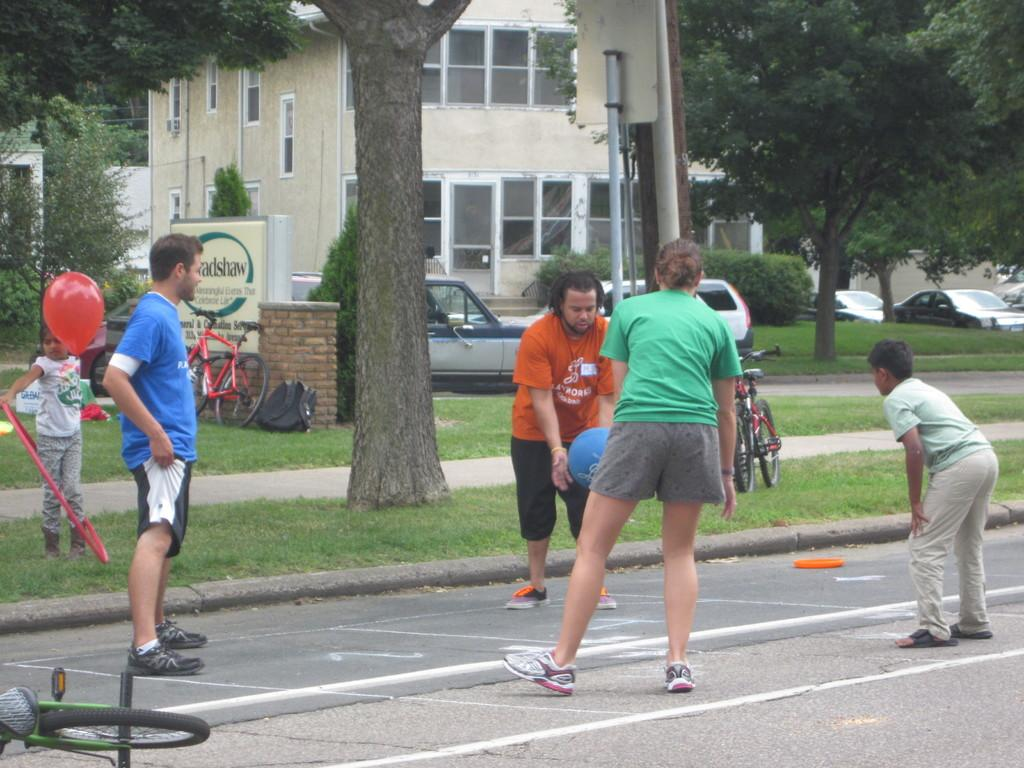What activity are the people in the image engaged in? The people in the image are playing a game. What type of vehicles can be seen in the image? There are bicycles and cars in the image. What type of vegetation is present in the image? There are green color trees in the image. What type of structure is visible in the image? There is a building in the image. Where can the store selling salt be found in the image? There is no store selling salt present in the image. What type of driving is taking place in the image? There is no driving activity depicted in the image; it features people playing a game and various vehicles parked or stationary. 